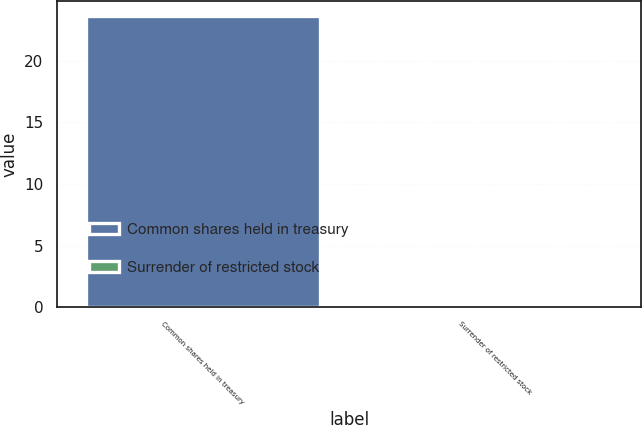<chart> <loc_0><loc_0><loc_500><loc_500><bar_chart><fcel>Common shares held in treasury<fcel>Surrender of restricted stock<nl><fcel>23.65<fcel>0.1<nl></chart> 